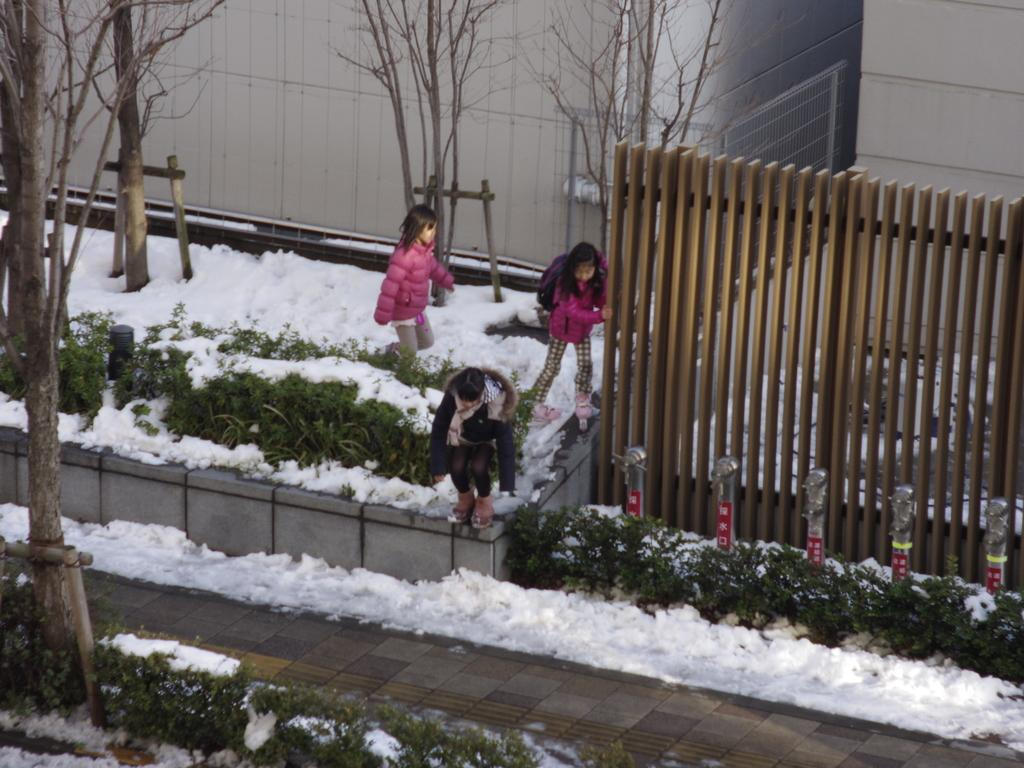How many kids are in the image? There are three kids in the image. What are the kids wearing? The kids are wearing pink jerseys. What can be seen behind the kids in the image? The kids are standing beside a fence. What is the condition of the landscape in the image? The landscape in the image is snowy. What type of yoke is being used by the kids in the image? There is no yoke present in the image; the kids are wearing pink jerseys and standing beside a fence. What do the kids believe in the image? There is no indication in the image of what the kids might believe. 